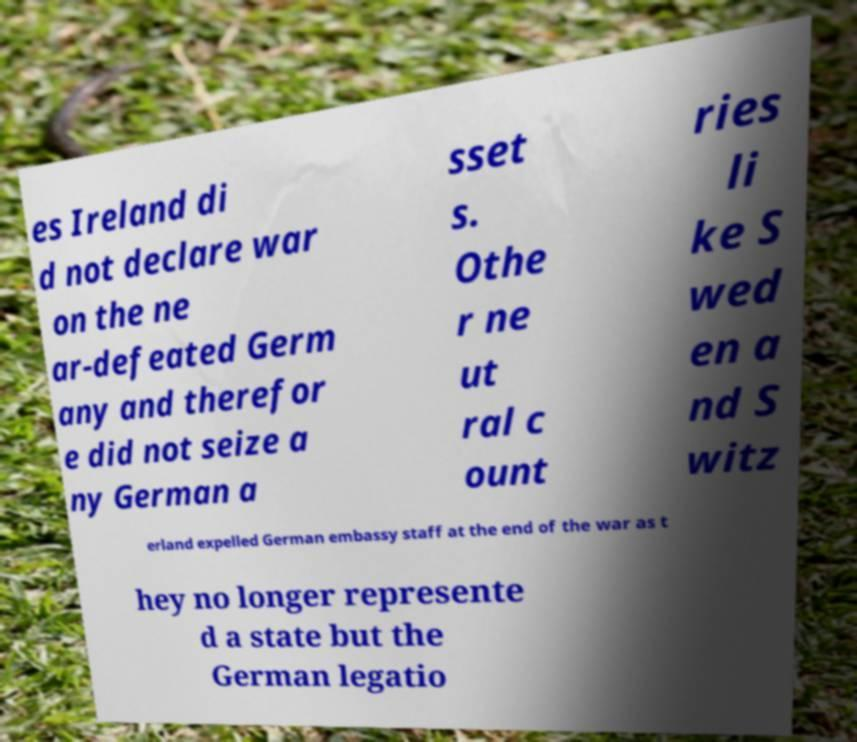Please read and relay the text visible in this image. What does it say? es Ireland di d not declare war on the ne ar-defeated Germ any and therefor e did not seize a ny German a sset s. Othe r ne ut ral c ount ries li ke S wed en a nd S witz erland expelled German embassy staff at the end of the war as t hey no longer represente d a state but the German legatio 